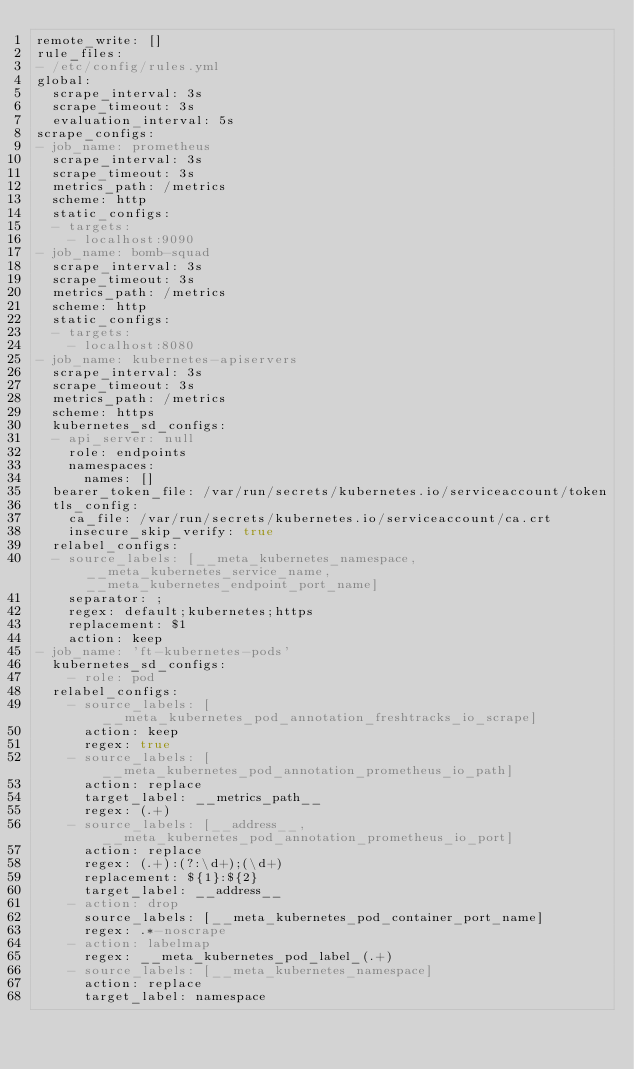Convert code to text. <code><loc_0><loc_0><loc_500><loc_500><_YAML_>remote_write: []
rule_files:
- /etc/config/rules.yml
global:
  scrape_interval: 3s
  scrape_timeout: 3s
  evaluation_interval: 5s
scrape_configs:
- job_name: prometheus
  scrape_interval: 3s
  scrape_timeout: 3s
  metrics_path: /metrics
  scheme: http
  static_configs:
  - targets:
    - localhost:9090
- job_name: bomb-squad
  scrape_interval: 3s
  scrape_timeout: 3s
  metrics_path: /metrics
  scheme: http
  static_configs:
  - targets:
    - localhost:8080
- job_name: kubernetes-apiservers
  scrape_interval: 3s
  scrape_timeout: 3s
  metrics_path: /metrics
  scheme: https
  kubernetes_sd_configs:
  - api_server: null
    role: endpoints
    namespaces:
      names: []
  bearer_token_file: /var/run/secrets/kubernetes.io/serviceaccount/token
  tls_config:
    ca_file: /var/run/secrets/kubernetes.io/serviceaccount/ca.crt
    insecure_skip_verify: true
  relabel_configs:
  - source_labels: [__meta_kubernetes_namespace, __meta_kubernetes_service_name, __meta_kubernetes_endpoint_port_name]
    separator: ;
    regex: default;kubernetes;https
    replacement: $1
    action: keep
- job_name: 'ft-kubernetes-pods'
  kubernetes_sd_configs:
    - role: pod
  relabel_configs:
    - source_labels: [__meta_kubernetes_pod_annotation_freshtracks_io_scrape]
      action: keep
      regex: true
    - source_labels: [__meta_kubernetes_pod_annotation_prometheus_io_path]
      action: replace
      target_label: __metrics_path__
      regex: (.+)
    - source_labels: [__address__, __meta_kubernetes_pod_annotation_prometheus_io_port]
      action: replace
      regex: (.+):(?:\d+);(\d+)
      replacement: ${1}:${2}
      target_label: __address__
    - action: drop
      source_labels: [__meta_kubernetes_pod_container_port_name]
      regex: .*-noscrape
    - action: labelmap
      regex: __meta_kubernetes_pod_label_(.+)
    - source_labels: [__meta_kubernetes_namespace]
      action: replace
      target_label: namespace</code> 